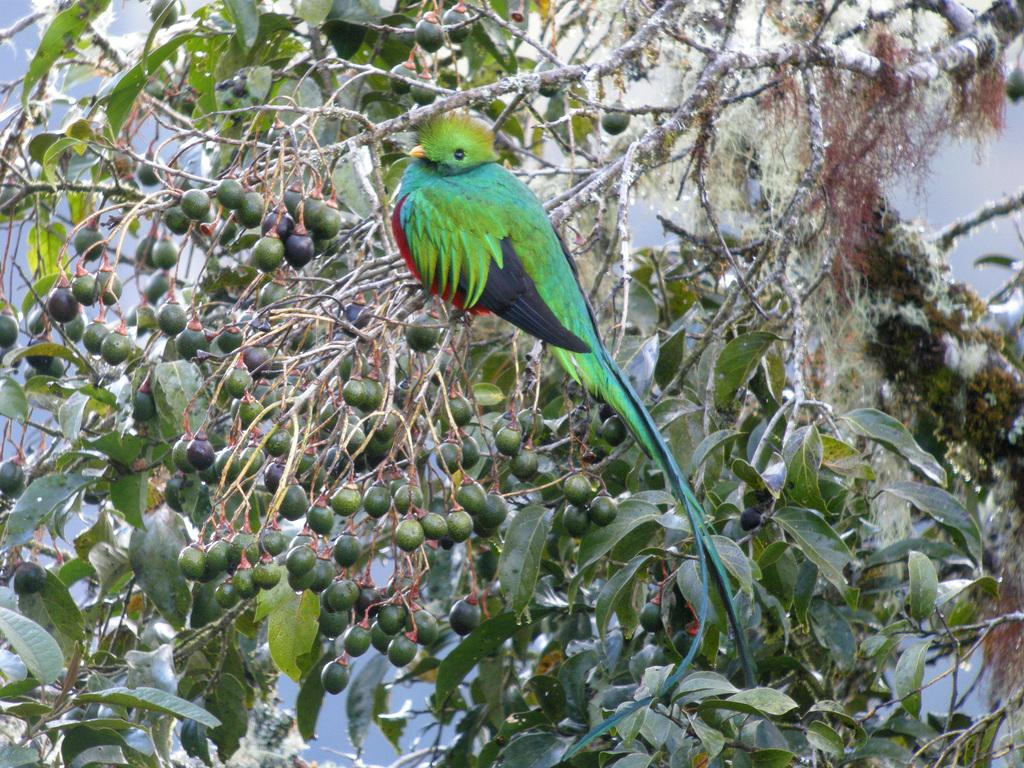What is present in the image that has fruits? There is a tree with fruits in the image. Can you describe the bird in the image? The bird is standing on the stem of the tree in the image. What type of brass instrument is the man playing in the image? There is no man or brass instrument present in the image; it features a tree with fruits and a bird. 